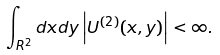<formula> <loc_0><loc_0><loc_500><loc_500>\int _ { { R } ^ { 2 } } d x d y \left | U ^ { ( 2 ) } ( x , y ) \right | < \infty .</formula> 